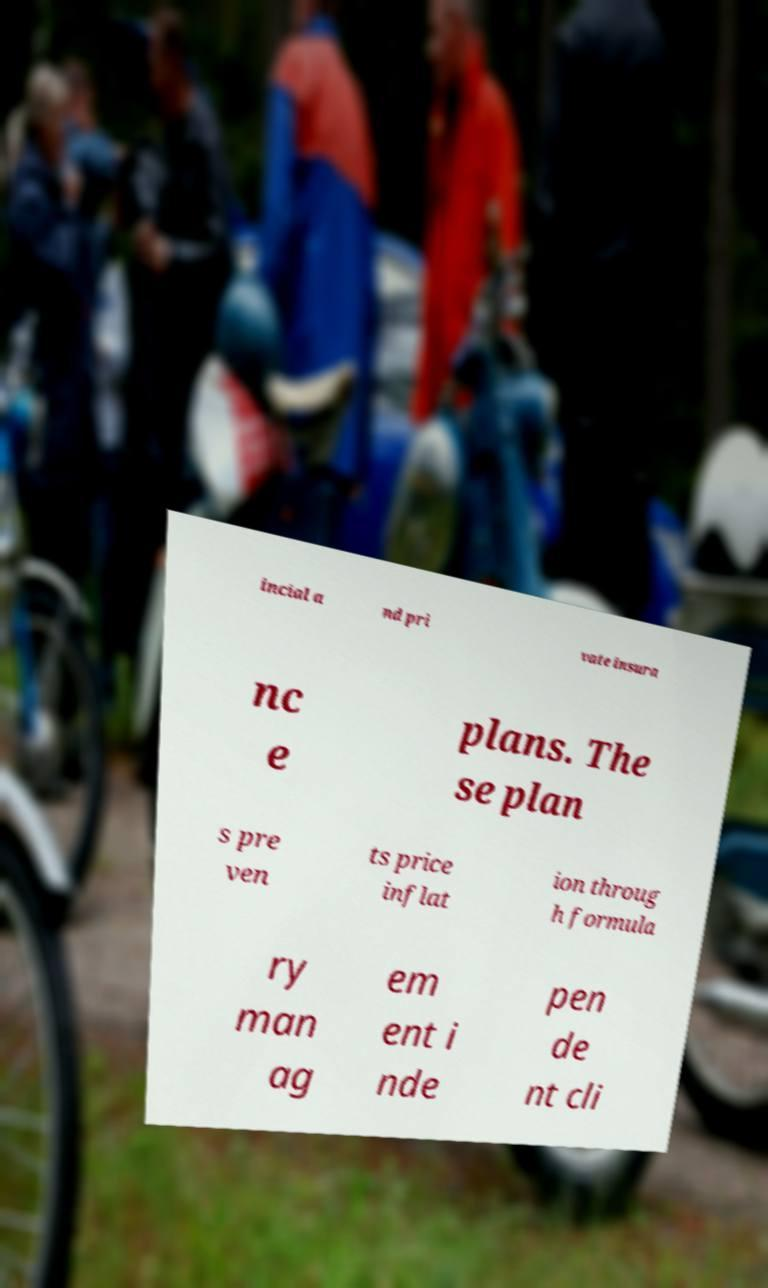I need the written content from this picture converted into text. Can you do that? incial a nd pri vate insura nc e plans. The se plan s pre ven ts price inflat ion throug h formula ry man ag em ent i nde pen de nt cli 